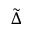<formula> <loc_0><loc_0><loc_500><loc_500>\tilde { \Delta }</formula> 